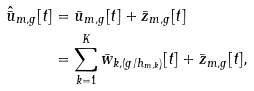Convert formula to latex. <formula><loc_0><loc_0><loc_500><loc_500>\hat { \bar { u } } _ { m , g } [ t ] & = \bar { u } _ { m , g } [ t ] + \bar { z } _ { m , g } [ t ] \\ & = \sum _ { k = 1 } ^ { K } \bar { w } _ { k , ( g / h _ { m , k } ) } [ t ] + \bar { z } _ { m , g } [ t ] ,</formula> 